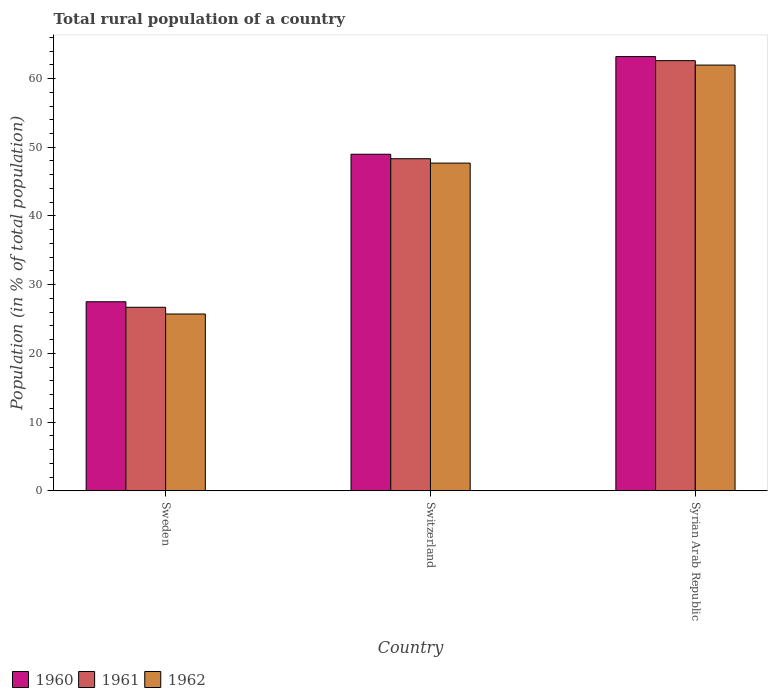How many different coloured bars are there?
Make the answer very short. 3. How many groups of bars are there?
Provide a succinct answer. 3. Are the number of bars per tick equal to the number of legend labels?
Provide a short and direct response. Yes. How many bars are there on the 3rd tick from the left?
Make the answer very short. 3. How many bars are there on the 1st tick from the right?
Give a very brief answer. 3. What is the label of the 2nd group of bars from the left?
Your response must be concise. Switzerland. What is the rural population in 1961 in Switzerland?
Your response must be concise. 48.33. Across all countries, what is the maximum rural population in 1960?
Provide a short and direct response. 63.19. Across all countries, what is the minimum rural population in 1960?
Your answer should be compact. 27.51. In which country was the rural population in 1960 maximum?
Offer a very short reply. Syrian Arab Republic. What is the total rural population in 1962 in the graph?
Offer a very short reply. 135.38. What is the difference between the rural population in 1960 in Sweden and that in Syrian Arab Republic?
Ensure brevity in your answer.  -35.68. What is the difference between the rural population in 1961 in Sweden and the rural population in 1962 in Syrian Arab Republic?
Make the answer very short. -35.25. What is the average rural population in 1960 per country?
Provide a succinct answer. 46.56. What is the difference between the rural population of/in 1960 and rural population of/in 1961 in Switzerland?
Make the answer very short. 0.65. In how many countries, is the rural population in 1961 greater than 54 %?
Give a very brief answer. 1. What is the ratio of the rural population in 1961 in Switzerland to that in Syrian Arab Republic?
Keep it short and to the point. 0.77. What is the difference between the highest and the second highest rural population in 1961?
Make the answer very short. 21.62. What is the difference between the highest and the lowest rural population in 1960?
Ensure brevity in your answer.  35.68. Is it the case that in every country, the sum of the rural population in 1961 and rural population in 1960 is greater than the rural population in 1962?
Keep it short and to the point. Yes. Are all the bars in the graph horizontal?
Offer a very short reply. No. What is the difference between two consecutive major ticks on the Y-axis?
Your answer should be compact. 10. Does the graph contain any zero values?
Your answer should be compact. No. How many legend labels are there?
Your answer should be very brief. 3. How are the legend labels stacked?
Give a very brief answer. Horizontal. What is the title of the graph?
Make the answer very short. Total rural population of a country. Does "1980" appear as one of the legend labels in the graph?
Provide a succinct answer. No. What is the label or title of the X-axis?
Ensure brevity in your answer.  Country. What is the label or title of the Y-axis?
Ensure brevity in your answer.  Population (in % of total population). What is the Population (in % of total population) of 1960 in Sweden?
Provide a succinct answer. 27.51. What is the Population (in % of total population) in 1961 in Sweden?
Your answer should be compact. 26.7. What is the Population (in % of total population) of 1962 in Sweden?
Your response must be concise. 25.73. What is the Population (in % of total population) in 1960 in Switzerland?
Keep it short and to the point. 48.98. What is the Population (in % of total population) of 1961 in Switzerland?
Ensure brevity in your answer.  48.33. What is the Population (in % of total population) in 1962 in Switzerland?
Make the answer very short. 47.69. What is the Population (in % of total population) of 1960 in Syrian Arab Republic?
Your answer should be compact. 63.19. What is the Population (in % of total population) in 1961 in Syrian Arab Republic?
Ensure brevity in your answer.  62.6. What is the Population (in % of total population) of 1962 in Syrian Arab Republic?
Offer a very short reply. 61.96. Across all countries, what is the maximum Population (in % of total population) of 1960?
Make the answer very short. 63.19. Across all countries, what is the maximum Population (in % of total population) of 1961?
Offer a terse response. 62.6. Across all countries, what is the maximum Population (in % of total population) in 1962?
Offer a terse response. 61.96. Across all countries, what is the minimum Population (in % of total population) of 1960?
Your answer should be compact. 27.51. Across all countries, what is the minimum Population (in % of total population) of 1961?
Offer a terse response. 26.7. Across all countries, what is the minimum Population (in % of total population) of 1962?
Offer a very short reply. 25.73. What is the total Population (in % of total population) of 1960 in the graph?
Ensure brevity in your answer.  139.68. What is the total Population (in % of total population) of 1961 in the graph?
Provide a succinct answer. 137.63. What is the total Population (in % of total population) in 1962 in the graph?
Ensure brevity in your answer.  135.38. What is the difference between the Population (in % of total population) in 1960 in Sweden and that in Switzerland?
Make the answer very short. -21.47. What is the difference between the Population (in % of total population) in 1961 in Sweden and that in Switzerland?
Provide a succinct answer. -21.62. What is the difference between the Population (in % of total population) of 1962 in Sweden and that in Switzerland?
Make the answer very short. -21.96. What is the difference between the Population (in % of total population) in 1960 in Sweden and that in Syrian Arab Republic?
Offer a terse response. -35.68. What is the difference between the Population (in % of total population) in 1961 in Sweden and that in Syrian Arab Republic?
Offer a terse response. -35.9. What is the difference between the Population (in % of total population) of 1962 in Sweden and that in Syrian Arab Republic?
Your answer should be very brief. -36.23. What is the difference between the Population (in % of total population) in 1960 in Switzerland and that in Syrian Arab Republic?
Make the answer very short. -14.21. What is the difference between the Population (in % of total population) of 1961 in Switzerland and that in Syrian Arab Republic?
Your answer should be very brief. -14.27. What is the difference between the Population (in % of total population) in 1962 in Switzerland and that in Syrian Arab Republic?
Offer a terse response. -14.27. What is the difference between the Population (in % of total population) of 1960 in Sweden and the Population (in % of total population) of 1961 in Switzerland?
Make the answer very short. -20.82. What is the difference between the Population (in % of total population) in 1960 in Sweden and the Population (in % of total population) in 1962 in Switzerland?
Ensure brevity in your answer.  -20.18. What is the difference between the Population (in % of total population) in 1961 in Sweden and the Population (in % of total population) in 1962 in Switzerland?
Make the answer very short. -20.99. What is the difference between the Population (in % of total population) in 1960 in Sweden and the Population (in % of total population) in 1961 in Syrian Arab Republic?
Keep it short and to the point. -35.09. What is the difference between the Population (in % of total population) of 1960 in Sweden and the Population (in % of total population) of 1962 in Syrian Arab Republic?
Your answer should be very brief. -34.45. What is the difference between the Population (in % of total population) in 1961 in Sweden and the Population (in % of total population) in 1962 in Syrian Arab Republic?
Provide a short and direct response. -35.25. What is the difference between the Population (in % of total population) of 1960 in Switzerland and the Population (in % of total population) of 1961 in Syrian Arab Republic?
Keep it short and to the point. -13.62. What is the difference between the Population (in % of total population) of 1960 in Switzerland and the Population (in % of total population) of 1962 in Syrian Arab Republic?
Ensure brevity in your answer.  -12.97. What is the difference between the Population (in % of total population) in 1961 in Switzerland and the Population (in % of total population) in 1962 in Syrian Arab Republic?
Make the answer very short. -13.63. What is the average Population (in % of total population) of 1960 per country?
Your answer should be very brief. 46.56. What is the average Population (in % of total population) of 1961 per country?
Your answer should be compact. 45.88. What is the average Population (in % of total population) in 1962 per country?
Give a very brief answer. 45.13. What is the difference between the Population (in % of total population) in 1960 and Population (in % of total population) in 1961 in Sweden?
Give a very brief answer. 0.81. What is the difference between the Population (in % of total population) in 1960 and Population (in % of total population) in 1962 in Sweden?
Your answer should be very brief. 1.78. What is the difference between the Population (in % of total population) of 1960 and Population (in % of total population) of 1961 in Switzerland?
Make the answer very short. 0.65. What is the difference between the Population (in % of total population) of 1960 and Population (in % of total population) of 1962 in Switzerland?
Offer a very short reply. 1.29. What is the difference between the Population (in % of total population) in 1961 and Population (in % of total population) in 1962 in Switzerland?
Make the answer very short. 0.64. What is the difference between the Population (in % of total population) of 1960 and Population (in % of total population) of 1961 in Syrian Arab Republic?
Provide a short and direct response. 0.59. What is the difference between the Population (in % of total population) in 1960 and Population (in % of total population) in 1962 in Syrian Arab Republic?
Your answer should be very brief. 1.24. What is the difference between the Population (in % of total population) of 1961 and Population (in % of total population) of 1962 in Syrian Arab Republic?
Provide a short and direct response. 0.65. What is the ratio of the Population (in % of total population) in 1960 in Sweden to that in Switzerland?
Give a very brief answer. 0.56. What is the ratio of the Population (in % of total population) of 1961 in Sweden to that in Switzerland?
Provide a short and direct response. 0.55. What is the ratio of the Population (in % of total population) of 1962 in Sweden to that in Switzerland?
Your response must be concise. 0.54. What is the ratio of the Population (in % of total population) of 1960 in Sweden to that in Syrian Arab Republic?
Provide a succinct answer. 0.44. What is the ratio of the Population (in % of total population) of 1961 in Sweden to that in Syrian Arab Republic?
Your response must be concise. 0.43. What is the ratio of the Population (in % of total population) in 1962 in Sweden to that in Syrian Arab Republic?
Ensure brevity in your answer.  0.42. What is the ratio of the Population (in % of total population) of 1960 in Switzerland to that in Syrian Arab Republic?
Offer a terse response. 0.78. What is the ratio of the Population (in % of total population) of 1961 in Switzerland to that in Syrian Arab Republic?
Your answer should be compact. 0.77. What is the ratio of the Population (in % of total population) in 1962 in Switzerland to that in Syrian Arab Republic?
Offer a terse response. 0.77. What is the difference between the highest and the second highest Population (in % of total population) in 1960?
Ensure brevity in your answer.  14.21. What is the difference between the highest and the second highest Population (in % of total population) in 1961?
Give a very brief answer. 14.27. What is the difference between the highest and the second highest Population (in % of total population) of 1962?
Ensure brevity in your answer.  14.27. What is the difference between the highest and the lowest Population (in % of total population) of 1960?
Offer a very short reply. 35.68. What is the difference between the highest and the lowest Population (in % of total population) of 1961?
Offer a terse response. 35.9. What is the difference between the highest and the lowest Population (in % of total population) in 1962?
Make the answer very short. 36.23. 